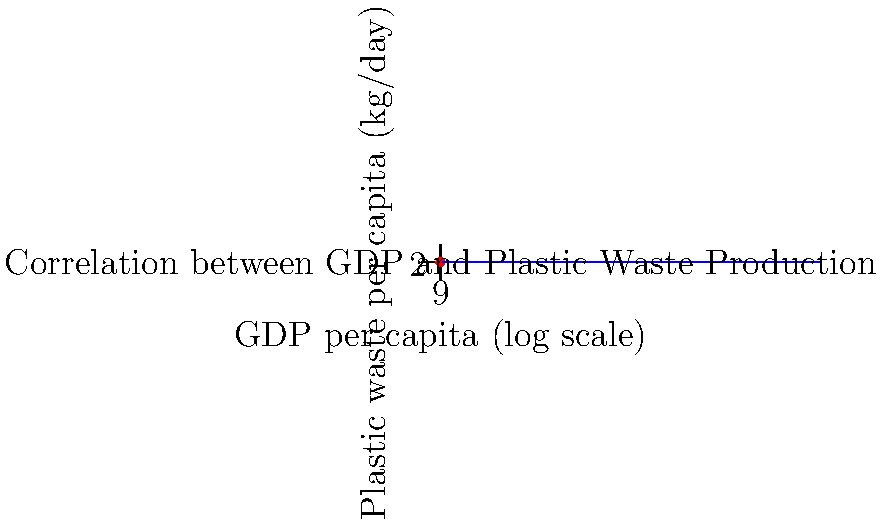Based on the scatter plot showing the relationship between GDP per capita (log scale) and plastic waste production per capita across countries, what conclusion can be drawn about the correlation between economic development and plastic pollution? To analyze the correlation between plastic waste production and GDP across countries using the scatter plot, we need to follow these steps:

1. Observe the general trend: As we move from left to right (increasing GDP), we see an upward trend in plastic waste production.

2. Assess the strength of the relationship: The points roughly follow a linear pattern, suggesting a strong positive correlation.

3. Interpret the logarithmic scale: The x-axis (GDP) is on a log scale, indicating that the relationship is not strictly linear but logarithmic.

4. Analyze the slope: The blue trend line shows a positive slope, confirming the positive relationship between GDP and plastic waste production.

5. Consider outliers: There don't appear to be significant outliers, which strengthens the observed relationship.

6. Interpret the implications: As countries become wealthier (higher GDP), they tend to produce more plastic waste per capita.

7. Sociological perspective: This trend suggests that economic development is associated with increased consumption patterns and potentially less sustainable practices regarding plastic use.

8. Policy implications: The data implies that as developing countries grow economically, they may face increasing challenges with plastic pollution unless preventive measures are implemented.

Given these observations, we can conclude that there is a strong positive correlation between economic development (as measured by GDP per capita) and plastic pollution (as measured by plastic waste production per capita).
Answer: Strong positive correlation between economic development and plastic pollution 